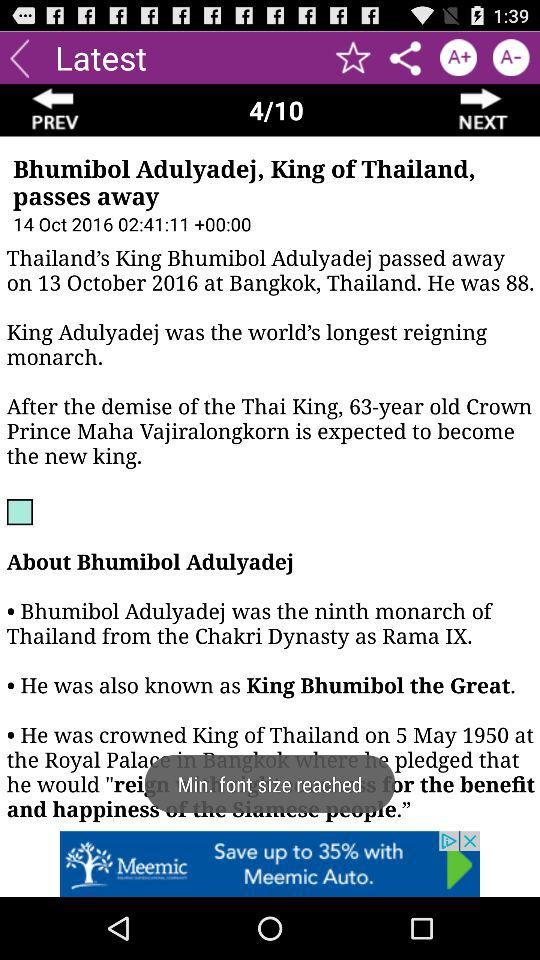When was Adulyadej crowned as King of Thailand? Adulyadej was crowned King of Thailand on May 5, 1950. 